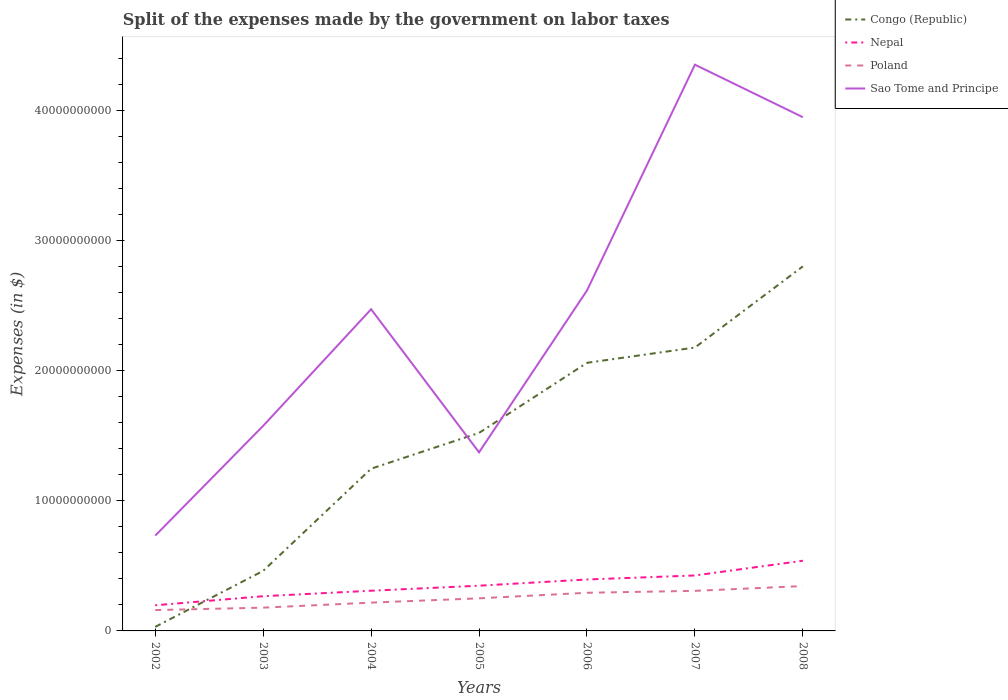Across all years, what is the maximum expenses made by the government on labor taxes in Poland?
Provide a succinct answer. 1.60e+09. In which year was the expenses made by the government on labor taxes in Poland maximum?
Your answer should be compact. 2002. What is the total expenses made by the government on labor taxes in Nepal in the graph?
Make the answer very short. -4.76e+08. What is the difference between the highest and the second highest expenses made by the government on labor taxes in Sao Tome and Principe?
Provide a short and direct response. 3.62e+1. What is the difference between the highest and the lowest expenses made by the government on labor taxes in Sao Tome and Principe?
Keep it short and to the point. 4. Is the expenses made by the government on labor taxes in Sao Tome and Principe strictly greater than the expenses made by the government on labor taxes in Congo (Republic) over the years?
Your response must be concise. No. How many years are there in the graph?
Give a very brief answer. 7. What is the difference between two consecutive major ticks on the Y-axis?
Offer a terse response. 1.00e+1. Does the graph contain any zero values?
Give a very brief answer. No. Where does the legend appear in the graph?
Give a very brief answer. Top right. How many legend labels are there?
Your answer should be compact. 4. How are the legend labels stacked?
Ensure brevity in your answer.  Vertical. What is the title of the graph?
Your answer should be very brief. Split of the expenses made by the government on labor taxes. What is the label or title of the Y-axis?
Your answer should be very brief. Expenses (in $). What is the Expenses (in $) of Congo (Republic) in 2002?
Give a very brief answer. 3.12e+08. What is the Expenses (in $) of Nepal in 2002?
Offer a terse response. 1.97e+09. What is the Expenses (in $) of Poland in 2002?
Offer a terse response. 1.60e+09. What is the Expenses (in $) in Sao Tome and Principe in 2002?
Provide a succinct answer. 7.32e+09. What is the Expenses (in $) of Congo (Republic) in 2003?
Give a very brief answer. 4.61e+09. What is the Expenses (in $) of Nepal in 2003?
Offer a terse response. 2.67e+09. What is the Expenses (in $) in Poland in 2003?
Your response must be concise. 1.79e+09. What is the Expenses (in $) of Sao Tome and Principe in 2003?
Provide a succinct answer. 1.58e+1. What is the Expenses (in $) of Congo (Republic) in 2004?
Provide a succinct answer. 1.25e+1. What is the Expenses (in $) in Nepal in 2004?
Your response must be concise. 3.09e+09. What is the Expenses (in $) of Poland in 2004?
Give a very brief answer. 2.17e+09. What is the Expenses (in $) of Sao Tome and Principe in 2004?
Keep it short and to the point. 2.47e+1. What is the Expenses (in $) of Congo (Republic) in 2005?
Your answer should be very brief. 1.52e+1. What is the Expenses (in $) of Nepal in 2005?
Offer a very short reply. 3.48e+09. What is the Expenses (in $) in Poland in 2005?
Offer a very short reply. 2.50e+09. What is the Expenses (in $) of Sao Tome and Principe in 2005?
Your answer should be compact. 1.37e+1. What is the Expenses (in $) in Congo (Republic) in 2006?
Your answer should be very brief. 2.06e+1. What is the Expenses (in $) of Nepal in 2006?
Your response must be concise. 3.95e+09. What is the Expenses (in $) in Poland in 2006?
Give a very brief answer. 2.93e+09. What is the Expenses (in $) of Sao Tome and Principe in 2006?
Give a very brief answer. 2.62e+1. What is the Expenses (in $) of Congo (Republic) in 2007?
Offer a very short reply. 2.18e+1. What is the Expenses (in $) of Nepal in 2007?
Make the answer very short. 4.26e+09. What is the Expenses (in $) of Poland in 2007?
Offer a very short reply. 3.08e+09. What is the Expenses (in $) in Sao Tome and Principe in 2007?
Make the answer very short. 4.35e+1. What is the Expenses (in $) of Congo (Republic) in 2008?
Your answer should be compact. 2.80e+1. What is the Expenses (in $) in Nepal in 2008?
Provide a short and direct response. 5.39e+09. What is the Expenses (in $) of Poland in 2008?
Your response must be concise. 3.44e+09. What is the Expenses (in $) of Sao Tome and Principe in 2008?
Give a very brief answer. 3.95e+1. Across all years, what is the maximum Expenses (in $) in Congo (Republic)?
Give a very brief answer. 2.80e+1. Across all years, what is the maximum Expenses (in $) of Nepal?
Offer a terse response. 5.39e+09. Across all years, what is the maximum Expenses (in $) in Poland?
Give a very brief answer. 3.44e+09. Across all years, what is the maximum Expenses (in $) in Sao Tome and Principe?
Offer a very short reply. 4.35e+1. Across all years, what is the minimum Expenses (in $) in Congo (Republic)?
Your answer should be compact. 3.12e+08. Across all years, what is the minimum Expenses (in $) in Nepal?
Make the answer very short. 1.97e+09. Across all years, what is the minimum Expenses (in $) of Poland?
Offer a very short reply. 1.60e+09. Across all years, what is the minimum Expenses (in $) of Sao Tome and Principe?
Offer a very short reply. 7.32e+09. What is the total Expenses (in $) of Congo (Republic) in the graph?
Ensure brevity in your answer.  1.03e+11. What is the total Expenses (in $) of Nepal in the graph?
Your response must be concise. 2.48e+1. What is the total Expenses (in $) in Poland in the graph?
Offer a terse response. 1.75e+1. What is the total Expenses (in $) in Sao Tome and Principe in the graph?
Your response must be concise. 1.71e+11. What is the difference between the Expenses (in $) of Congo (Republic) in 2002 and that in 2003?
Keep it short and to the point. -4.30e+09. What is the difference between the Expenses (in $) in Nepal in 2002 and that in 2003?
Your answer should be very brief. -6.97e+08. What is the difference between the Expenses (in $) of Poland in 2002 and that in 2003?
Ensure brevity in your answer.  -1.87e+08. What is the difference between the Expenses (in $) of Sao Tome and Principe in 2002 and that in 2003?
Provide a succinct answer. -8.43e+09. What is the difference between the Expenses (in $) in Congo (Republic) in 2002 and that in 2004?
Provide a short and direct response. -1.22e+1. What is the difference between the Expenses (in $) of Nepal in 2002 and that in 2004?
Offer a terse response. -1.12e+09. What is the difference between the Expenses (in $) in Poland in 2002 and that in 2004?
Make the answer very short. -5.73e+08. What is the difference between the Expenses (in $) in Sao Tome and Principe in 2002 and that in 2004?
Make the answer very short. -1.74e+1. What is the difference between the Expenses (in $) in Congo (Republic) in 2002 and that in 2005?
Make the answer very short. -1.49e+1. What is the difference between the Expenses (in $) of Nepal in 2002 and that in 2005?
Make the answer very short. -1.51e+09. What is the difference between the Expenses (in $) in Poland in 2002 and that in 2005?
Offer a very short reply. -9.03e+08. What is the difference between the Expenses (in $) of Sao Tome and Principe in 2002 and that in 2005?
Offer a terse response. -6.40e+09. What is the difference between the Expenses (in $) of Congo (Republic) in 2002 and that in 2006?
Your response must be concise. -2.03e+1. What is the difference between the Expenses (in $) in Nepal in 2002 and that in 2006?
Give a very brief answer. -1.98e+09. What is the difference between the Expenses (in $) in Poland in 2002 and that in 2006?
Your answer should be compact. -1.33e+09. What is the difference between the Expenses (in $) in Sao Tome and Principe in 2002 and that in 2006?
Make the answer very short. -1.88e+1. What is the difference between the Expenses (in $) of Congo (Republic) in 2002 and that in 2007?
Provide a succinct answer. -2.15e+1. What is the difference between the Expenses (in $) in Nepal in 2002 and that in 2007?
Give a very brief answer. -2.29e+09. What is the difference between the Expenses (in $) of Poland in 2002 and that in 2007?
Provide a succinct answer. -1.48e+09. What is the difference between the Expenses (in $) in Sao Tome and Principe in 2002 and that in 2007?
Your response must be concise. -3.62e+1. What is the difference between the Expenses (in $) of Congo (Republic) in 2002 and that in 2008?
Provide a short and direct response. -2.77e+1. What is the difference between the Expenses (in $) in Nepal in 2002 and that in 2008?
Provide a short and direct response. -3.42e+09. What is the difference between the Expenses (in $) of Poland in 2002 and that in 2008?
Your answer should be very brief. -1.84e+09. What is the difference between the Expenses (in $) of Sao Tome and Principe in 2002 and that in 2008?
Your answer should be compact. -3.21e+1. What is the difference between the Expenses (in $) of Congo (Republic) in 2003 and that in 2004?
Your answer should be very brief. -7.85e+09. What is the difference between the Expenses (in $) in Nepal in 2003 and that in 2004?
Your answer should be very brief. -4.22e+08. What is the difference between the Expenses (in $) of Poland in 2003 and that in 2004?
Provide a short and direct response. -3.86e+08. What is the difference between the Expenses (in $) of Sao Tome and Principe in 2003 and that in 2004?
Provide a short and direct response. -8.96e+09. What is the difference between the Expenses (in $) of Congo (Republic) in 2003 and that in 2005?
Your answer should be very brief. -1.06e+1. What is the difference between the Expenses (in $) of Nepal in 2003 and that in 2005?
Offer a very short reply. -8.08e+08. What is the difference between the Expenses (in $) of Poland in 2003 and that in 2005?
Give a very brief answer. -7.16e+08. What is the difference between the Expenses (in $) in Sao Tome and Principe in 2003 and that in 2005?
Your response must be concise. 2.03e+09. What is the difference between the Expenses (in $) of Congo (Republic) in 2003 and that in 2006?
Give a very brief answer. -1.60e+1. What is the difference between the Expenses (in $) in Nepal in 2003 and that in 2006?
Offer a terse response. -1.28e+09. What is the difference between the Expenses (in $) in Poland in 2003 and that in 2006?
Provide a short and direct response. -1.14e+09. What is the difference between the Expenses (in $) of Sao Tome and Principe in 2003 and that in 2006?
Provide a short and direct response. -1.04e+1. What is the difference between the Expenses (in $) of Congo (Republic) in 2003 and that in 2007?
Ensure brevity in your answer.  -1.72e+1. What is the difference between the Expenses (in $) of Nepal in 2003 and that in 2007?
Your answer should be compact. -1.59e+09. What is the difference between the Expenses (in $) of Poland in 2003 and that in 2007?
Your answer should be compact. -1.29e+09. What is the difference between the Expenses (in $) in Sao Tome and Principe in 2003 and that in 2007?
Offer a terse response. -2.77e+1. What is the difference between the Expenses (in $) of Congo (Republic) in 2003 and that in 2008?
Provide a short and direct response. -2.34e+1. What is the difference between the Expenses (in $) in Nepal in 2003 and that in 2008?
Your response must be concise. -2.72e+09. What is the difference between the Expenses (in $) of Poland in 2003 and that in 2008?
Offer a very short reply. -1.66e+09. What is the difference between the Expenses (in $) of Sao Tome and Principe in 2003 and that in 2008?
Your response must be concise. -2.37e+1. What is the difference between the Expenses (in $) in Congo (Republic) in 2004 and that in 2005?
Make the answer very short. -2.75e+09. What is the difference between the Expenses (in $) of Nepal in 2004 and that in 2005?
Make the answer very short. -3.86e+08. What is the difference between the Expenses (in $) of Poland in 2004 and that in 2005?
Keep it short and to the point. -3.30e+08. What is the difference between the Expenses (in $) in Sao Tome and Principe in 2004 and that in 2005?
Keep it short and to the point. 1.10e+1. What is the difference between the Expenses (in $) in Congo (Republic) in 2004 and that in 2006?
Your response must be concise. -8.14e+09. What is the difference between the Expenses (in $) of Nepal in 2004 and that in 2006?
Offer a very short reply. -8.63e+08. What is the difference between the Expenses (in $) in Poland in 2004 and that in 2006?
Make the answer very short. -7.57e+08. What is the difference between the Expenses (in $) of Sao Tome and Principe in 2004 and that in 2006?
Your answer should be compact. -1.44e+09. What is the difference between the Expenses (in $) of Congo (Republic) in 2004 and that in 2007?
Give a very brief answer. -9.31e+09. What is the difference between the Expenses (in $) in Nepal in 2004 and that in 2007?
Offer a terse response. -1.17e+09. What is the difference between the Expenses (in $) in Poland in 2004 and that in 2007?
Provide a short and direct response. -9.06e+08. What is the difference between the Expenses (in $) in Sao Tome and Principe in 2004 and that in 2007?
Your answer should be very brief. -1.88e+1. What is the difference between the Expenses (in $) of Congo (Republic) in 2004 and that in 2008?
Your answer should be compact. -1.55e+1. What is the difference between the Expenses (in $) in Nepal in 2004 and that in 2008?
Your answer should be very brief. -2.30e+09. What is the difference between the Expenses (in $) in Poland in 2004 and that in 2008?
Offer a terse response. -1.27e+09. What is the difference between the Expenses (in $) in Sao Tome and Principe in 2004 and that in 2008?
Your response must be concise. -1.48e+1. What is the difference between the Expenses (in $) in Congo (Republic) in 2005 and that in 2006?
Your response must be concise. -5.38e+09. What is the difference between the Expenses (in $) of Nepal in 2005 and that in 2006?
Make the answer very short. -4.76e+08. What is the difference between the Expenses (in $) in Poland in 2005 and that in 2006?
Provide a succinct answer. -4.27e+08. What is the difference between the Expenses (in $) of Sao Tome and Principe in 2005 and that in 2006?
Provide a short and direct response. -1.24e+1. What is the difference between the Expenses (in $) of Congo (Republic) in 2005 and that in 2007?
Give a very brief answer. -6.56e+09. What is the difference between the Expenses (in $) of Nepal in 2005 and that in 2007?
Your response must be concise. -7.86e+08. What is the difference between the Expenses (in $) in Poland in 2005 and that in 2007?
Provide a succinct answer. -5.76e+08. What is the difference between the Expenses (in $) in Sao Tome and Principe in 2005 and that in 2007?
Your answer should be very brief. -2.98e+1. What is the difference between the Expenses (in $) in Congo (Republic) in 2005 and that in 2008?
Your response must be concise. -1.28e+1. What is the difference between the Expenses (in $) in Nepal in 2005 and that in 2008?
Give a very brief answer. -1.92e+09. What is the difference between the Expenses (in $) of Poland in 2005 and that in 2008?
Provide a succinct answer. -9.41e+08. What is the difference between the Expenses (in $) of Sao Tome and Principe in 2005 and that in 2008?
Offer a terse response. -2.57e+1. What is the difference between the Expenses (in $) of Congo (Republic) in 2006 and that in 2007?
Keep it short and to the point. -1.17e+09. What is the difference between the Expenses (in $) of Nepal in 2006 and that in 2007?
Offer a terse response. -3.10e+08. What is the difference between the Expenses (in $) in Poland in 2006 and that in 2007?
Offer a very short reply. -1.49e+08. What is the difference between the Expenses (in $) in Sao Tome and Principe in 2006 and that in 2007?
Offer a terse response. -1.73e+1. What is the difference between the Expenses (in $) of Congo (Republic) in 2006 and that in 2008?
Your answer should be compact. -7.41e+09. What is the difference between the Expenses (in $) of Nepal in 2006 and that in 2008?
Ensure brevity in your answer.  -1.44e+09. What is the difference between the Expenses (in $) in Poland in 2006 and that in 2008?
Your answer should be very brief. -5.14e+08. What is the difference between the Expenses (in $) of Sao Tome and Principe in 2006 and that in 2008?
Your answer should be very brief. -1.33e+1. What is the difference between the Expenses (in $) in Congo (Republic) in 2007 and that in 2008?
Provide a short and direct response. -6.24e+09. What is the difference between the Expenses (in $) in Nepal in 2007 and that in 2008?
Keep it short and to the point. -1.13e+09. What is the difference between the Expenses (in $) in Poland in 2007 and that in 2008?
Your answer should be very brief. -3.65e+08. What is the difference between the Expenses (in $) in Sao Tome and Principe in 2007 and that in 2008?
Ensure brevity in your answer.  4.03e+09. What is the difference between the Expenses (in $) of Congo (Republic) in 2002 and the Expenses (in $) of Nepal in 2003?
Provide a short and direct response. -2.36e+09. What is the difference between the Expenses (in $) in Congo (Republic) in 2002 and the Expenses (in $) in Poland in 2003?
Your answer should be compact. -1.48e+09. What is the difference between the Expenses (in $) of Congo (Republic) in 2002 and the Expenses (in $) of Sao Tome and Principe in 2003?
Make the answer very short. -1.54e+1. What is the difference between the Expenses (in $) in Nepal in 2002 and the Expenses (in $) in Poland in 2003?
Offer a very short reply. 1.82e+08. What is the difference between the Expenses (in $) in Nepal in 2002 and the Expenses (in $) in Sao Tome and Principe in 2003?
Provide a succinct answer. -1.38e+1. What is the difference between the Expenses (in $) of Poland in 2002 and the Expenses (in $) of Sao Tome and Principe in 2003?
Your answer should be very brief. -1.42e+1. What is the difference between the Expenses (in $) in Congo (Republic) in 2002 and the Expenses (in $) in Nepal in 2004?
Offer a very short reply. -2.78e+09. What is the difference between the Expenses (in $) of Congo (Republic) in 2002 and the Expenses (in $) of Poland in 2004?
Offer a terse response. -1.86e+09. What is the difference between the Expenses (in $) of Congo (Republic) in 2002 and the Expenses (in $) of Sao Tome and Principe in 2004?
Your response must be concise. -2.44e+1. What is the difference between the Expenses (in $) in Nepal in 2002 and the Expenses (in $) in Poland in 2004?
Make the answer very short. -2.04e+08. What is the difference between the Expenses (in $) of Nepal in 2002 and the Expenses (in $) of Sao Tome and Principe in 2004?
Your answer should be compact. -2.27e+1. What is the difference between the Expenses (in $) in Poland in 2002 and the Expenses (in $) in Sao Tome and Principe in 2004?
Your answer should be very brief. -2.31e+1. What is the difference between the Expenses (in $) in Congo (Republic) in 2002 and the Expenses (in $) in Nepal in 2005?
Keep it short and to the point. -3.16e+09. What is the difference between the Expenses (in $) of Congo (Republic) in 2002 and the Expenses (in $) of Poland in 2005?
Make the answer very short. -2.19e+09. What is the difference between the Expenses (in $) of Congo (Republic) in 2002 and the Expenses (in $) of Sao Tome and Principe in 2005?
Provide a succinct answer. -1.34e+1. What is the difference between the Expenses (in $) in Nepal in 2002 and the Expenses (in $) in Poland in 2005?
Your answer should be compact. -5.34e+08. What is the difference between the Expenses (in $) in Nepal in 2002 and the Expenses (in $) in Sao Tome and Principe in 2005?
Your answer should be compact. -1.18e+1. What is the difference between the Expenses (in $) of Poland in 2002 and the Expenses (in $) of Sao Tome and Principe in 2005?
Offer a very short reply. -1.21e+1. What is the difference between the Expenses (in $) in Congo (Republic) in 2002 and the Expenses (in $) in Nepal in 2006?
Offer a terse response. -3.64e+09. What is the difference between the Expenses (in $) of Congo (Republic) in 2002 and the Expenses (in $) of Poland in 2006?
Provide a short and direct response. -2.62e+09. What is the difference between the Expenses (in $) in Congo (Republic) in 2002 and the Expenses (in $) in Sao Tome and Principe in 2006?
Offer a very short reply. -2.58e+1. What is the difference between the Expenses (in $) in Nepal in 2002 and the Expenses (in $) in Poland in 2006?
Provide a succinct answer. -9.61e+08. What is the difference between the Expenses (in $) in Nepal in 2002 and the Expenses (in $) in Sao Tome and Principe in 2006?
Ensure brevity in your answer.  -2.42e+1. What is the difference between the Expenses (in $) in Poland in 2002 and the Expenses (in $) in Sao Tome and Principe in 2006?
Offer a very short reply. -2.46e+1. What is the difference between the Expenses (in $) of Congo (Republic) in 2002 and the Expenses (in $) of Nepal in 2007?
Ensure brevity in your answer.  -3.95e+09. What is the difference between the Expenses (in $) of Congo (Republic) in 2002 and the Expenses (in $) of Poland in 2007?
Your answer should be compact. -2.77e+09. What is the difference between the Expenses (in $) of Congo (Republic) in 2002 and the Expenses (in $) of Sao Tome and Principe in 2007?
Your answer should be compact. -4.32e+1. What is the difference between the Expenses (in $) in Nepal in 2002 and the Expenses (in $) in Poland in 2007?
Your response must be concise. -1.11e+09. What is the difference between the Expenses (in $) of Nepal in 2002 and the Expenses (in $) of Sao Tome and Principe in 2007?
Your answer should be very brief. -4.15e+1. What is the difference between the Expenses (in $) of Poland in 2002 and the Expenses (in $) of Sao Tome and Principe in 2007?
Your answer should be very brief. -4.19e+1. What is the difference between the Expenses (in $) in Congo (Republic) in 2002 and the Expenses (in $) in Nepal in 2008?
Your answer should be compact. -5.08e+09. What is the difference between the Expenses (in $) of Congo (Republic) in 2002 and the Expenses (in $) of Poland in 2008?
Your answer should be compact. -3.13e+09. What is the difference between the Expenses (in $) in Congo (Republic) in 2002 and the Expenses (in $) in Sao Tome and Principe in 2008?
Make the answer very short. -3.92e+1. What is the difference between the Expenses (in $) of Nepal in 2002 and the Expenses (in $) of Poland in 2008?
Provide a succinct answer. -1.48e+09. What is the difference between the Expenses (in $) in Nepal in 2002 and the Expenses (in $) in Sao Tome and Principe in 2008?
Offer a terse response. -3.75e+1. What is the difference between the Expenses (in $) in Poland in 2002 and the Expenses (in $) in Sao Tome and Principe in 2008?
Make the answer very short. -3.79e+1. What is the difference between the Expenses (in $) of Congo (Republic) in 2003 and the Expenses (in $) of Nepal in 2004?
Offer a very short reply. 1.53e+09. What is the difference between the Expenses (in $) in Congo (Republic) in 2003 and the Expenses (in $) in Poland in 2004?
Make the answer very short. 2.44e+09. What is the difference between the Expenses (in $) in Congo (Republic) in 2003 and the Expenses (in $) in Sao Tome and Principe in 2004?
Ensure brevity in your answer.  -2.01e+1. What is the difference between the Expenses (in $) in Nepal in 2003 and the Expenses (in $) in Poland in 2004?
Give a very brief answer. 4.93e+08. What is the difference between the Expenses (in $) in Nepal in 2003 and the Expenses (in $) in Sao Tome and Principe in 2004?
Give a very brief answer. -2.20e+1. What is the difference between the Expenses (in $) in Poland in 2003 and the Expenses (in $) in Sao Tome and Principe in 2004?
Offer a terse response. -2.29e+1. What is the difference between the Expenses (in $) of Congo (Republic) in 2003 and the Expenses (in $) of Nepal in 2005?
Provide a short and direct response. 1.14e+09. What is the difference between the Expenses (in $) in Congo (Republic) in 2003 and the Expenses (in $) in Poland in 2005?
Your answer should be compact. 2.11e+09. What is the difference between the Expenses (in $) of Congo (Republic) in 2003 and the Expenses (in $) of Sao Tome and Principe in 2005?
Your response must be concise. -9.11e+09. What is the difference between the Expenses (in $) in Nepal in 2003 and the Expenses (in $) in Poland in 2005?
Offer a very short reply. 1.63e+08. What is the difference between the Expenses (in $) of Nepal in 2003 and the Expenses (in $) of Sao Tome and Principe in 2005?
Give a very brief answer. -1.11e+1. What is the difference between the Expenses (in $) of Poland in 2003 and the Expenses (in $) of Sao Tome and Principe in 2005?
Provide a succinct answer. -1.19e+1. What is the difference between the Expenses (in $) in Congo (Republic) in 2003 and the Expenses (in $) in Nepal in 2006?
Make the answer very short. 6.63e+08. What is the difference between the Expenses (in $) of Congo (Republic) in 2003 and the Expenses (in $) of Poland in 2006?
Offer a terse response. 1.68e+09. What is the difference between the Expenses (in $) in Congo (Republic) in 2003 and the Expenses (in $) in Sao Tome and Principe in 2006?
Offer a very short reply. -2.15e+1. What is the difference between the Expenses (in $) in Nepal in 2003 and the Expenses (in $) in Poland in 2006?
Make the answer very short. -2.64e+08. What is the difference between the Expenses (in $) of Nepal in 2003 and the Expenses (in $) of Sao Tome and Principe in 2006?
Ensure brevity in your answer.  -2.35e+1. What is the difference between the Expenses (in $) of Poland in 2003 and the Expenses (in $) of Sao Tome and Principe in 2006?
Keep it short and to the point. -2.44e+1. What is the difference between the Expenses (in $) in Congo (Republic) in 2003 and the Expenses (in $) in Nepal in 2007?
Give a very brief answer. 3.53e+08. What is the difference between the Expenses (in $) of Congo (Republic) in 2003 and the Expenses (in $) of Poland in 2007?
Give a very brief answer. 1.53e+09. What is the difference between the Expenses (in $) of Congo (Republic) in 2003 and the Expenses (in $) of Sao Tome and Principe in 2007?
Your answer should be very brief. -3.89e+1. What is the difference between the Expenses (in $) of Nepal in 2003 and the Expenses (in $) of Poland in 2007?
Provide a succinct answer. -4.13e+08. What is the difference between the Expenses (in $) in Nepal in 2003 and the Expenses (in $) in Sao Tome and Principe in 2007?
Provide a short and direct response. -4.08e+1. What is the difference between the Expenses (in $) of Poland in 2003 and the Expenses (in $) of Sao Tome and Principe in 2007?
Provide a short and direct response. -4.17e+1. What is the difference between the Expenses (in $) of Congo (Republic) in 2003 and the Expenses (in $) of Nepal in 2008?
Provide a short and direct response. -7.77e+08. What is the difference between the Expenses (in $) of Congo (Republic) in 2003 and the Expenses (in $) of Poland in 2008?
Offer a very short reply. 1.17e+09. What is the difference between the Expenses (in $) of Congo (Republic) in 2003 and the Expenses (in $) of Sao Tome and Principe in 2008?
Your answer should be very brief. -3.49e+1. What is the difference between the Expenses (in $) of Nepal in 2003 and the Expenses (in $) of Poland in 2008?
Give a very brief answer. -7.78e+08. What is the difference between the Expenses (in $) in Nepal in 2003 and the Expenses (in $) in Sao Tome and Principe in 2008?
Give a very brief answer. -3.68e+1. What is the difference between the Expenses (in $) in Poland in 2003 and the Expenses (in $) in Sao Tome and Principe in 2008?
Your answer should be compact. -3.77e+1. What is the difference between the Expenses (in $) in Congo (Republic) in 2004 and the Expenses (in $) in Nepal in 2005?
Ensure brevity in your answer.  8.99e+09. What is the difference between the Expenses (in $) in Congo (Republic) in 2004 and the Expenses (in $) in Poland in 2005?
Give a very brief answer. 9.96e+09. What is the difference between the Expenses (in $) of Congo (Republic) in 2004 and the Expenses (in $) of Sao Tome and Principe in 2005?
Give a very brief answer. -1.26e+09. What is the difference between the Expenses (in $) of Nepal in 2004 and the Expenses (in $) of Poland in 2005?
Ensure brevity in your answer.  5.85e+08. What is the difference between the Expenses (in $) in Nepal in 2004 and the Expenses (in $) in Sao Tome and Principe in 2005?
Give a very brief answer. -1.06e+1. What is the difference between the Expenses (in $) in Poland in 2004 and the Expenses (in $) in Sao Tome and Principe in 2005?
Offer a terse response. -1.15e+1. What is the difference between the Expenses (in $) of Congo (Republic) in 2004 and the Expenses (in $) of Nepal in 2006?
Offer a very short reply. 8.51e+09. What is the difference between the Expenses (in $) in Congo (Republic) in 2004 and the Expenses (in $) in Poland in 2006?
Your answer should be compact. 9.53e+09. What is the difference between the Expenses (in $) in Congo (Republic) in 2004 and the Expenses (in $) in Sao Tome and Principe in 2006?
Ensure brevity in your answer.  -1.37e+1. What is the difference between the Expenses (in $) in Nepal in 2004 and the Expenses (in $) in Poland in 2006?
Provide a succinct answer. 1.58e+08. What is the difference between the Expenses (in $) in Nepal in 2004 and the Expenses (in $) in Sao Tome and Principe in 2006?
Make the answer very short. -2.31e+1. What is the difference between the Expenses (in $) in Poland in 2004 and the Expenses (in $) in Sao Tome and Principe in 2006?
Provide a short and direct response. -2.40e+1. What is the difference between the Expenses (in $) in Congo (Republic) in 2004 and the Expenses (in $) in Nepal in 2007?
Your answer should be very brief. 8.20e+09. What is the difference between the Expenses (in $) of Congo (Republic) in 2004 and the Expenses (in $) of Poland in 2007?
Provide a short and direct response. 9.38e+09. What is the difference between the Expenses (in $) of Congo (Republic) in 2004 and the Expenses (in $) of Sao Tome and Principe in 2007?
Keep it short and to the point. -3.10e+1. What is the difference between the Expenses (in $) in Nepal in 2004 and the Expenses (in $) in Poland in 2007?
Your answer should be compact. 8.70e+06. What is the difference between the Expenses (in $) of Nepal in 2004 and the Expenses (in $) of Sao Tome and Principe in 2007?
Your answer should be compact. -4.04e+1. What is the difference between the Expenses (in $) in Poland in 2004 and the Expenses (in $) in Sao Tome and Principe in 2007?
Provide a short and direct response. -4.13e+1. What is the difference between the Expenses (in $) in Congo (Republic) in 2004 and the Expenses (in $) in Nepal in 2008?
Provide a short and direct response. 7.07e+09. What is the difference between the Expenses (in $) of Congo (Republic) in 2004 and the Expenses (in $) of Poland in 2008?
Your answer should be very brief. 9.02e+09. What is the difference between the Expenses (in $) in Congo (Republic) in 2004 and the Expenses (in $) in Sao Tome and Principe in 2008?
Provide a succinct answer. -2.70e+1. What is the difference between the Expenses (in $) of Nepal in 2004 and the Expenses (in $) of Poland in 2008?
Provide a short and direct response. -3.56e+08. What is the difference between the Expenses (in $) of Nepal in 2004 and the Expenses (in $) of Sao Tome and Principe in 2008?
Your answer should be compact. -3.64e+1. What is the difference between the Expenses (in $) of Poland in 2004 and the Expenses (in $) of Sao Tome and Principe in 2008?
Ensure brevity in your answer.  -3.73e+1. What is the difference between the Expenses (in $) in Congo (Republic) in 2005 and the Expenses (in $) in Nepal in 2006?
Provide a short and direct response. 1.13e+1. What is the difference between the Expenses (in $) in Congo (Republic) in 2005 and the Expenses (in $) in Poland in 2006?
Ensure brevity in your answer.  1.23e+1. What is the difference between the Expenses (in $) of Congo (Republic) in 2005 and the Expenses (in $) of Sao Tome and Principe in 2006?
Your response must be concise. -1.09e+1. What is the difference between the Expenses (in $) in Nepal in 2005 and the Expenses (in $) in Poland in 2006?
Make the answer very short. 5.44e+08. What is the difference between the Expenses (in $) in Nepal in 2005 and the Expenses (in $) in Sao Tome and Principe in 2006?
Offer a very short reply. -2.27e+1. What is the difference between the Expenses (in $) in Poland in 2005 and the Expenses (in $) in Sao Tome and Principe in 2006?
Ensure brevity in your answer.  -2.37e+1. What is the difference between the Expenses (in $) in Congo (Republic) in 2005 and the Expenses (in $) in Nepal in 2007?
Provide a short and direct response. 1.10e+1. What is the difference between the Expenses (in $) of Congo (Republic) in 2005 and the Expenses (in $) of Poland in 2007?
Give a very brief answer. 1.21e+1. What is the difference between the Expenses (in $) of Congo (Republic) in 2005 and the Expenses (in $) of Sao Tome and Principe in 2007?
Keep it short and to the point. -2.83e+1. What is the difference between the Expenses (in $) in Nepal in 2005 and the Expenses (in $) in Poland in 2007?
Your answer should be compact. 3.95e+08. What is the difference between the Expenses (in $) of Nepal in 2005 and the Expenses (in $) of Sao Tome and Principe in 2007?
Give a very brief answer. -4.00e+1. What is the difference between the Expenses (in $) in Poland in 2005 and the Expenses (in $) in Sao Tome and Principe in 2007?
Your answer should be compact. -4.10e+1. What is the difference between the Expenses (in $) in Congo (Republic) in 2005 and the Expenses (in $) in Nepal in 2008?
Offer a very short reply. 9.82e+09. What is the difference between the Expenses (in $) of Congo (Republic) in 2005 and the Expenses (in $) of Poland in 2008?
Give a very brief answer. 1.18e+1. What is the difference between the Expenses (in $) of Congo (Republic) in 2005 and the Expenses (in $) of Sao Tome and Principe in 2008?
Make the answer very short. -2.43e+1. What is the difference between the Expenses (in $) of Nepal in 2005 and the Expenses (in $) of Poland in 2008?
Ensure brevity in your answer.  3.01e+07. What is the difference between the Expenses (in $) in Nepal in 2005 and the Expenses (in $) in Sao Tome and Principe in 2008?
Ensure brevity in your answer.  -3.60e+1. What is the difference between the Expenses (in $) of Poland in 2005 and the Expenses (in $) of Sao Tome and Principe in 2008?
Provide a succinct answer. -3.70e+1. What is the difference between the Expenses (in $) of Congo (Republic) in 2006 and the Expenses (in $) of Nepal in 2007?
Offer a very short reply. 1.63e+1. What is the difference between the Expenses (in $) in Congo (Republic) in 2006 and the Expenses (in $) in Poland in 2007?
Give a very brief answer. 1.75e+1. What is the difference between the Expenses (in $) of Congo (Republic) in 2006 and the Expenses (in $) of Sao Tome and Principe in 2007?
Your response must be concise. -2.29e+1. What is the difference between the Expenses (in $) in Nepal in 2006 and the Expenses (in $) in Poland in 2007?
Your answer should be very brief. 8.71e+08. What is the difference between the Expenses (in $) of Nepal in 2006 and the Expenses (in $) of Sao Tome and Principe in 2007?
Your answer should be compact. -3.96e+1. What is the difference between the Expenses (in $) of Poland in 2006 and the Expenses (in $) of Sao Tome and Principe in 2007?
Give a very brief answer. -4.06e+1. What is the difference between the Expenses (in $) in Congo (Republic) in 2006 and the Expenses (in $) in Nepal in 2008?
Offer a very short reply. 1.52e+1. What is the difference between the Expenses (in $) in Congo (Republic) in 2006 and the Expenses (in $) in Poland in 2008?
Provide a short and direct response. 1.72e+1. What is the difference between the Expenses (in $) of Congo (Republic) in 2006 and the Expenses (in $) of Sao Tome and Principe in 2008?
Keep it short and to the point. -1.89e+1. What is the difference between the Expenses (in $) in Nepal in 2006 and the Expenses (in $) in Poland in 2008?
Offer a terse response. 5.06e+08. What is the difference between the Expenses (in $) of Nepal in 2006 and the Expenses (in $) of Sao Tome and Principe in 2008?
Offer a very short reply. -3.55e+1. What is the difference between the Expenses (in $) in Poland in 2006 and the Expenses (in $) in Sao Tome and Principe in 2008?
Your answer should be very brief. -3.65e+1. What is the difference between the Expenses (in $) in Congo (Republic) in 2007 and the Expenses (in $) in Nepal in 2008?
Your answer should be compact. 1.64e+1. What is the difference between the Expenses (in $) in Congo (Republic) in 2007 and the Expenses (in $) in Poland in 2008?
Offer a terse response. 1.83e+1. What is the difference between the Expenses (in $) in Congo (Republic) in 2007 and the Expenses (in $) in Sao Tome and Principe in 2008?
Your answer should be very brief. -1.77e+1. What is the difference between the Expenses (in $) of Nepal in 2007 and the Expenses (in $) of Poland in 2008?
Provide a short and direct response. 8.16e+08. What is the difference between the Expenses (in $) in Nepal in 2007 and the Expenses (in $) in Sao Tome and Principe in 2008?
Give a very brief answer. -3.52e+1. What is the difference between the Expenses (in $) of Poland in 2007 and the Expenses (in $) of Sao Tome and Principe in 2008?
Make the answer very short. -3.64e+1. What is the average Expenses (in $) in Congo (Republic) per year?
Your answer should be compact. 1.47e+1. What is the average Expenses (in $) of Nepal per year?
Provide a succinct answer. 3.54e+09. What is the average Expenses (in $) in Poland per year?
Your response must be concise. 2.50e+09. What is the average Expenses (in $) of Sao Tome and Principe per year?
Your answer should be very brief. 2.44e+1. In the year 2002, what is the difference between the Expenses (in $) in Congo (Republic) and Expenses (in $) in Nepal?
Ensure brevity in your answer.  -1.66e+09. In the year 2002, what is the difference between the Expenses (in $) in Congo (Republic) and Expenses (in $) in Poland?
Make the answer very short. -1.29e+09. In the year 2002, what is the difference between the Expenses (in $) of Congo (Republic) and Expenses (in $) of Sao Tome and Principe?
Make the answer very short. -7.01e+09. In the year 2002, what is the difference between the Expenses (in $) of Nepal and Expenses (in $) of Poland?
Provide a succinct answer. 3.69e+08. In the year 2002, what is the difference between the Expenses (in $) in Nepal and Expenses (in $) in Sao Tome and Principe?
Offer a very short reply. -5.35e+09. In the year 2002, what is the difference between the Expenses (in $) in Poland and Expenses (in $) in Sao Tome and Principe?
Keep it short and to the point. -5.72e+09. In the year 2003, what is the difference between the Expenses (in $) in Congo (Republic) and Expenses (in $) in Nepal?
Your answer should be very brief. 1.95e+09. In the year 2003, what is the difference between the Expenses (in $) in Congo (Republic) and Expenses (in $) in Poland?
Ensure brevity in your answer.  2.83e+09. In the year 2003, what is the difference between the Expenses (in $) in Congo (Republic) and Expenses (in $) in Sao Tome and Principe?
Offer a terse response. -1.11e+1. In the year 2003, what is the difference between the Expenses (in $) in Nepal and Expenses (in $) in Poland?
Keep it short and to the point. 8.79e+08. In the year 2003, what is the difference between the Expenses (in $) in Nepal and Expenses (in $) in Sao Tome and Principe?
Make the answer very short. -1.31e+1. In the year 2003, what is the difference between the Expenses (in $) of Poland and Expenses (in $) of Sao Tome and Principe?
Provide a short and direct response. -1.40e+1. In the year 2004, what is the difference between the Expenses (in $) of Congo (Republic) and Expenses (in $) of Nepal?
Your answer should be compact. 9.38e+09. In the year 2004, what is the difference between the Expenses (in $) in Congo (Republic) and Expenses (in $) in Poland?
Provide a succinct answer. 1.03e+1. In the year 2004, what is the difference between the Expenses (in $) of Congo (Republic) and Expenses (in $) of Sao Tome and Principe?
Offer a very short reply. -1.23e+1. In the year 2004, what is the difference between the Expenses (in $) in Nepal and Expenses (in $) in Poland?
Offer a terse response. 9.15e+08. In the year 2004, what is the difference between the Expenses (in $) in Nepal and Expenses (in $) in Sao Tome and Principe?
Your answer should be compact. -2.16e+1. In the year 2004, what is the difference between the Expenses (in $) of Poland and Expenses (in $) of Sao Tome and Principe?
Keep it short and to the point. -2.25e+1. In the year 2005, what is the difference between the Expenses (in $) of Congo (Republic) and Expenses (in $) of Nepal?
Offer a very short reply. 1.17e+1. In the year 2005, what is the difference between the Expenses (in $) of Congo (Republic) and Expenses (in $) of Poland?
Your answer should be compact. 1.27e+1. In the year 2005, what is the difference between the Expenses (in $) of Congo (Republic) and Expenses (in $) of Sao Tome and Principe?
Ensure brevity in your answer.  1.49e+09. In the year 2005, what is the difference between the Expenses (in $) in Nepal and Expenses (in $) in Poland?
Provide a succinct answer. 9.71e+08. In the year 2005, what is the difference between the Expenses (in $) of Nepal and Expenses (in $) of Sao Tome and Principe?
Your response must be concise. -1.02e+1. In the year 2005, what is the difference between the Expenses (in $) in Poland and Expenses (in $) in Sao Tome and Principe?
Offer a very short reply. -1.12e+1. In the year 2006, what is the difference between the Expenses (in $) in Congo (Republic) and Expenses (in $) in Nepal?
Offer a very short reply. 1.66e+1. In the year 2006, what is the difference between the Expenses (in $) in Congo (Republic) and Expenses (in $) in Poland?
Your answer should be very brief. 1.77e+1. In the year 2006, what is the difference between the Expenses (in $) in Congo (Republic) and Expenses (in $) in Sao Tome and Principe?
Your response must be concise. -5.56e+09. In the year 2006, what is the difference between the Expenses (in $) in Nepal and Expenses (in $) in Poland?
Your answer should be compact. 1.02e+09. In the year 2006, what is the difference between the Expenses (in $) in Nepal and Expenses (in $) in Sao Tome and Principe?
Give a very brief answer. -2.22e+1. In the year 2006, what is the difference between the Expenses (in $) in Poland and Expenses (in $) in Sao Tome and Principe?
Your answer should be compact. -2.32e+1. In the year 2007, what is the difference between the Expenses (in $) in Congo (Republic) and Expenses (in $) in Nepal?
Keep it short and to the point. 1.75e+1. In the year 2007, what is the difference between the Expenses (in $) in Congo (Republic) and Expenses (in $) in Poland?
Provide a short and direct response. 1.87e+1. In the year 2007, what is the difference between the Expenses (in $) of Congo (Republic) and Expenses (in $) of Sao Tome and Principe?
Offer a very short reply. -2.17e+1. In the year 2007, what is the difference between the Expenses (in $) in Nepal and Expenses (in $) in Poland?
Provide a short and direct response. 1.18e+09. In the year 2007, what is the difference between the Expenses (in $) of Nepal and Expenses (in $) of Sao Tome and Principe?
Offer a terse response. -3.92e+1. In the year 2007, what is the difference between the Expenses (in $) in Poland and Expenses (in $) in Sao Tome and Principe?
Offer a terse response. -4.04e+1. In the year 2008, what is the difference between the Expenses (in $) of Congo (Republic) and Expenses (in $) of Nepal?
Make the answer very short. 2.26e+1. In the year 2008, what is the difference between the Expenses (in $) in Congo (Republic) and Expenses (in $) in Poland?
Your answer should be very brief. 2.46e+1. In the year 2008, what is the difference between the Expenses (in $) of Congo (Republic) and Expenses (in $) of Sao Tome and Principe?
Give a very brief answer. -1.15e+1. In the year 2008, what is the difference between the Expenses (in $) in Nepal and Expenses (in $) in Poland?
Provide a succinct answer. 1.95e+09. In the year 2008, what is the difference between the Expenses (in $) in Nepal and Expenses (in $) in Sao Tome and Principe?
Give a very brief answer. -3.41e+1. In the year 2008, what is the difference between the Expenses (in $) of Poland and Expenses (in $) of Sao Tome and Principe?
Provide a short and direct response. -3.60e+1. What is the ratio of the Expenses (in $) of Congo (Republic) in 2002 to that in 2003?
Offer a very short reply. 0.07. What is the ratio of the Expenses (in $) in Nepal in 2002 to that in 2003?
Offer a very short reply. 0.74. What is the ratio of the Expenses (in $) in Poland in 2002 to that in 2003?
Offer a very short reply. 0.9. What is the ratio of the Expenses (in $) in Sao Tome and Principe in 2002 to that in 2003?
Ensure brevity in your answer.  0.46. What is the ratio of the Expenses (in $) of Congo (Republic) in 2002 to that in 2004?
Make the answer very short. 0.03. What is the ratio of the Expenses (in $) in Nepal in 2002 to that in 2004?
Your answer should be compact. 0.64. What is the ratio of the Expenses (in $) of Poland in 2002 to that in 2004?
Make the answer very short. 0.74. What is the ratio of the Expenses (in $) of Sao Tome and Principe in 2002 to that in 2004?
Give a very brief answer. 0.3. What is the ratio of the Expenses (in $) in Congo (Republic) in 2002 to that in 2005?
Give a very brief answer. 0.02. What is the ratio of the Expenses (in $) of Nepal in 2002 to that in 2005?
Provide a succinct answer. 0.57. What is the ratio of the Expenses (in $) in Poland in 2002 to that in 2005?
Offer a very short reply. 0.64. What is the ratio of the Expenses (in $) of Sao Tome and Principe in 2002 to that in 2005?
Ensure brevity in your answer.  0.53. What is the ratio of the Expenses (in $) in Congo (Republic) in 2002 to that in 2006?
Ensure brevity in your answer.  0.02. What is the ratio of the Expenses (in $) of Nepal in 2002 to that in 2006?
Your answer should be very brief. 0.5. What is the ratio of the Expenses (in $) of Poland in 2002 to that in 2006?
Offer a very short reply. 0.55. What is the ratio of the Expenses (in $) in Sao Tome and Principe in 2002 to that in 2006?
Make the answer very short. 0.28. What is the ratio of the Expenses (in $) of Congo (Republic) in 2002 to that in 2007?
Ensure brevity in your answer.  0.01. What is the ratio of the Expenses (in $) in Nepal in 2002 to that in 2007?
Keep it short and to the point. 0.46. What is the ratio of the Expenses (in $) of Poland in 2002 to that in 2007?
Provide a succinct answer. 0.52. What is the ratio of the Expenses (in $) in Sao Tome and Principe in 2002 to that in 2007?
Offer a very short reply. 0.17. What is the ratio of the Expenses (in $) of Congo (Republic) in 2002 to that in 2008?
Your response must be concise. 0.01. What is the ratio of the Expenses (in $) of Nepal in 2002 to that in 2008?
Give a very brief answer. 0.37. What is the ratio of the Expenses (in $) of Poland in 2002 to that in 2008?
Your response must be concise. 0.46. What is the ratio of the Expenses (in $) of Sao Tome and Principe in 2002 to that in 2008?
Make the answer very short. 0.19. What is the ratio of the Expenses (in $) of Congo (Republic) in 2003 to that in 2004?
Keep it short and to the point. 0.37. What is the ratio of the Expenses (in $) in Nepal in 2003 to that in 2004?
Give a very brief answer. 0.86. What is the ratio of the Expenses (in $) of Poland in 2003 to that in 2004?
Ensure brevity in your answer.  0.82. What is the ratio of the Expenses (in $) of Sao Tome and Principe in 2003 to that in 2004?
Provide a succinct answer. 0.64. What is the ratio of the Expenses (in $) of Congo (Republic) in 2003 to that in 2005?
Provide a short and direct response. 0.3. What is the ratio of the Expenses (in $) in Nepal in 2003 to that in 2005?
Your answer should be very brief. 0.77. What is the ratio of the Expenses (in $) of Poland in 2003 to that in 2005?
Your answer should be compact. 0.71. What is the ratio of the Expenses (in $) in Sao Tome and Principe in 2003 to that in 2005?
Provide a succinct answer. 1.15. What is the ratio of the Expenses (in $) of Congo (Republic) in 2003 to that in 2006?
Offer a terse response. 0.22. What is the ratio of the Expenses (in $) in Nepal in 2003 to that in 2006?
Your answer should be compact. 0.67. What is the ratio of the Expenses (in $) in Poland in 2003 to that in 2006?
Ensure brevity in your answer.  0.61. What is the ratio of the Expenses (in $) of Sao Tome and Principe in 2003 to that in 2006?
Provide a short and direct response. 0.6. What is the ratio of the Expenses (in $) of Congo (Republic) in 2003 to that in 2007?
Offer a terse response. 0.21. What is the ratio of the Expenses (in $) in Nepal in 2003 to that in 2007?
Provide a succinct answer. 0.63. What is the ratio of the Expenses (in $) in Poland in 2003 to that in 2007?
Keep it short and to the point. 0.58. What is the ratio of the Expenses (in $) of Sao Tome and Principe in 2003 to that in 2007?
Keep it short and to the point. 0.36. What is the ratio of the Expenses (in $) in Congo (Republic) in 2003 to that in 2008?
Your response must be concise. 0.16. What is the ratio of the Expenses (in $) in Nepal in 2003 to that in 2008?
Your answer should be very brief. 0.49. What is the ratio of the Expenses (in $) in Poland in 2003 to that in 2008?
Your answer should be compact. 0.52. What is the ratio of the Expenses (in $) of Sao Tome and Principe in 2003 to that in 2008?
Provide a short and direct response. 0.4. What is the ratio of the Expenses (in $) of Congo (Republic) in 2004 to that in 2005?
Provide a short and direct response. 0.82. What is the ratio of the Expenses (in $) in Nepal in 2004 to that in 2005?
Keep it short and to the point. 0.89. What is the ratio of the Expenses (in $) of Poland in 2004 to that in 2005?
Keep it short and to the point. 0.87. What is the ratio of the Expenses (in $) in Sao Tome and Principe in 2004 to that in 2005?
Give a very brief answer. 1.8. What is the ratio of the Expenses (in $) of Congo (Republic) in 2004 to that in 2006?
Provide a succinct answer. 0.61. What is the ratio of the Expenses (in $) in Nepal in 2004 to that in 2006?
Provide a short and direct response. 0.78. What is the ratio of the Expenses (in $) of Poland in 2004 to that in 2006?
Offer a very short reply. 0.74. What is the ratio of the Expenses (in $) of Sao Tome and Principe in 2004 to that in 2006?
Ensure brevity in your answer.  0.94. What is the ratio of the Expenses (in $) in Congo (Republic) in 2004 to that in 2007?
Your response must be concise. 0.57. What is the ratio of the Expenses (in $) in Nepal in 2004 to that in 2007?
Ensure brevity in your answer.  0.72. What is the ratio of the Expenses (in $) of Poland in 2004 to that in 2007?
Keep it short and to the point. 0.71. What is the ratio of the Expenses (in $) in Sao Tome and Principe in 2004 to that in 2007?
Provide a succinct answer. 0.57. What is the ratio of the Expenses (in $) of Congo (Republic) in 2004 to that in 2008?
Provide a short and direct response. 0.45. What is the ratio of the Expenses (in $) of Nepal in 2004 to that in 2008?
Offer a very short reply. 0.57. What is the ratio of the Expenses (in $) in Poland in 2004 to that in 2008?
Offer a terse response. 0.63. What is the ratio of the Expenses (in $) in Sao Tome and Principe in 2004 to that in 2008?
Your answer should be compact. 0.63. What is the ratio of the Expenses (in $) of Congo (Republic) in 2005 to that in 2006?
Your answer should be very brief. 0.74. What is the ratio of the Expenses (in $) in Nepal in 2005 to that in 2006?
Ensure brevity in your answer.  0.88. What is the ratio of the Expenses (in $) in Poland in 2005 to that in 2006?
Offer a very short reply. 0.85. What is the ratio of the Expenses (in $) in Sao Tome and Principe in 2005 to that in 2006?
Keep it short and to the point. 0.52. What is the ratio of the Expenses (in $) in Congo (Republic) in 2005 to that in 2007?
Your response must be concise. 0.7. What is the ratio of the Expenses (in $) of Nepal in 2005 to that in 2007?
Give a very brief answer. 0.82. What is the ratio of the Expenses (in $) in Poland in 2005 to that in 2007?
Your answer should be very brief. 0.81. What is the ratio of the Expenses (in $) of Sao Tome and Principe in 2005 to that in 2007?
Offer a terse response. 0.32. What is the ratio of the Expenses (in $) of Congo (Republic) in 2005 to that in 2008?
Keep it short and to the point. 0.54. What is the ratio of the Expenses (in $) in Nepal in 2005 to that in 2008?
Provide a succinct answer. 0.64. What is the ratio of the Expenses (in $) in Poland in 2005 to that in 2008?
Your response must be concise. 0.73. What is the ratio of the Expenses (in $) in Sao Tome and Principe in 2005 to that in 2008?
Offer a terse response. 0.35. What is the ratio of the Expenses (in $) in Congo (Republic) in 2006 to that in 2007?
Provide a succinct answer. 0.95. What is the ratio of the Expenses (in $) of Nepal in 2006 to that in 2007?
Provide a short and direct response. 0.93. What is the ratio of the Expenses (in $) in Poland in 2006 to that in 2007?
Your answer should be compact. 0.95. What is the ratio of the Expenses (in $) in Sao Tome and Principe in 2006 to that in 2007?
Your response must be concise. 0.6. What is the ratio of the Expenses (in $) in Congo (Republic) in 2006 to that in 2008?
Ensure brevity in your answer.  0.74. What is the ratio of the Expenses (in $) in Nepal in 2006 to that in 2008?
Keep it short and to the point. 0.73. What is the ratio of the Expenses (in $) of Poland in 2006 to that in 2008?
Provide a succinct answer. 0.85. What is the ratio of the Expenses (in $) in Sao Tome and Principe in 2006 to that in 2008?
Provide a short and direct response. 0.66. What is the ratio of the Expenses (in $) of Congo (Republic) in 2007 to that in 2008?
Offer a terse response. 0.78. What is the ratio of the Expenses (in $) of Nepal in 2007 to that in 2008?
Your response must be concise. 0.79. What is the ratio of the Expenses (in $) in Poland in 2007 to that in 2008?
Give a very brief answer. 0.89. What is the ratio of the Expenses (in $) of Sao Tome and Principe in 2007 to that in 2008?
Ensure brevity in your answer.  1.1. What is the difference between the highest and the second highest Expenses (in $) in Congo (Republic)?
Ensure brevity in your answer.  6.24e+09. What is the difference between the highest and the second highest Expenses (in $) in Nepal?
Give a very brief answer. 1.13e+09. What is the difference between the highest and the second highest Expenses (in $) of Poland?
Provide a succinct answer. 3.65e+08. What is the difference between the highest and the second highest Expenses (in $) of Sao Tome and Principe?
Provide a succinct answer. 4.03e+09. What is the difference between the highest and the lowest Expenses (in $) of Congo (Republic)?
Your response must be concise. 2.77e+1. What is the difference between the highest and the lowest Expenses (in $) of Nepal?
Provide a succinct answer. 3.42e+09. What is the difference between the highest and the lowest Expenses (in $) of Poland?
Offer a very short reply. 1.84e+09. What is the difference between the highest and the lowest Expenses (in $) of Sao Tome and Principe?
Ensure brevity in your answer.  3.62e+1. 